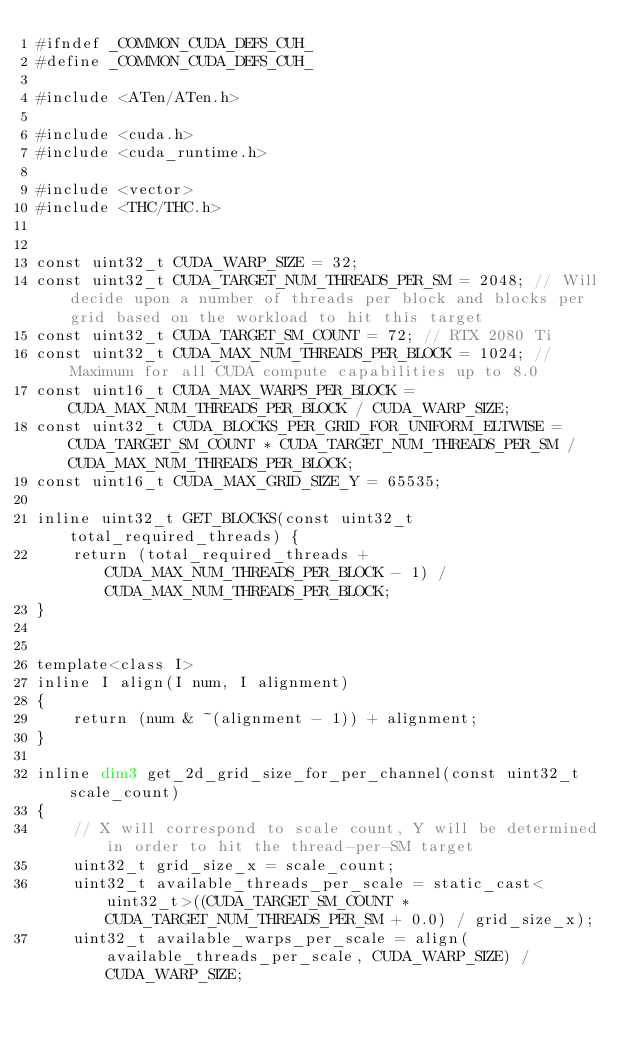Convert code to text. <code><loc_0><loc_0><loc_500><loc_500><_Cuda_>#ifndef _COMMON_CUDA_DEFS_CUH_
#define _COMMON_CUDA_DEFS_CUH_

#include <ATen/ATen.h>

#include <cuda.h>
#include <cuda_runtime.h>

#include <vector>
#include <THC/THC.h>


const uint32_t CUDA_WARP_SIZE = 32;
const uint32_t CUDA_TARGET_NUM_THREADS_PER_SM = 2048; // Will decide upon a number of threads per block and blocks per grid based on the workload to hit this target
const uint32_t CUDA_TARGET_SM_COUNT = 72; // RTX 2080 Ti
const uint32_t CUDA_MAX_NUM_THREADS_PER_BLOCK = 1024; // Maximum for all CUDA compute capabilities up to 8.0
const uint16_t CUDA_MAX_WARPS_PER_BLOCK = CUDA_MAX_NUM_THREADS_PER_BLOCK / CUDA_WARP_SIZE;
const uint32_t CUDA_BLOCKS_PER_GRID_FOR_UNIFORM_ELTWISE = CUDA_TARGET_SM_COUNT * CUDA_TARGET_NUM_THREADS_PER_SM / CUDA_MAX_NUM_THREADS_PER_BLOCK;
const uint16_t CUDA_MAX_GRID_SIZE_Y = 65535;

inline uint32_t GET_BLOCKS(const uint32_t total_required_threads) {
    return (total_required_threads + CUDA_MAX_NUM_THREADS_PER_BLOCK - 1) / CUDA_MAX_NUM_THREADS_PER_BLOCK;
}


template<class I>
inline I align(I num, I alignment)
{
    return (num & ~(alignment - 1)) + alignment;
}

inline dim3 get_2d_grid_size_for_per_channel(const uint32_t scale_count)
{
    // X will correspond to scale count, Y will be determined in order to hit the thread-per-SM target
    uint32_t grid_size_x = scale_count;
    uint32_t available_threads_per_scale = static_cast<uint32_t>((CUDA_TARGET_SM_COUNT * CUDA_TARGET_NUM_THREADS_PER_SM + 0.0) / grid_size_x);
    uint32_t available_warps_per_scale = align(available_threads_per_scale, CUDA_WARP_SIZE) / CUDA_WARP_SIZE;</code> 